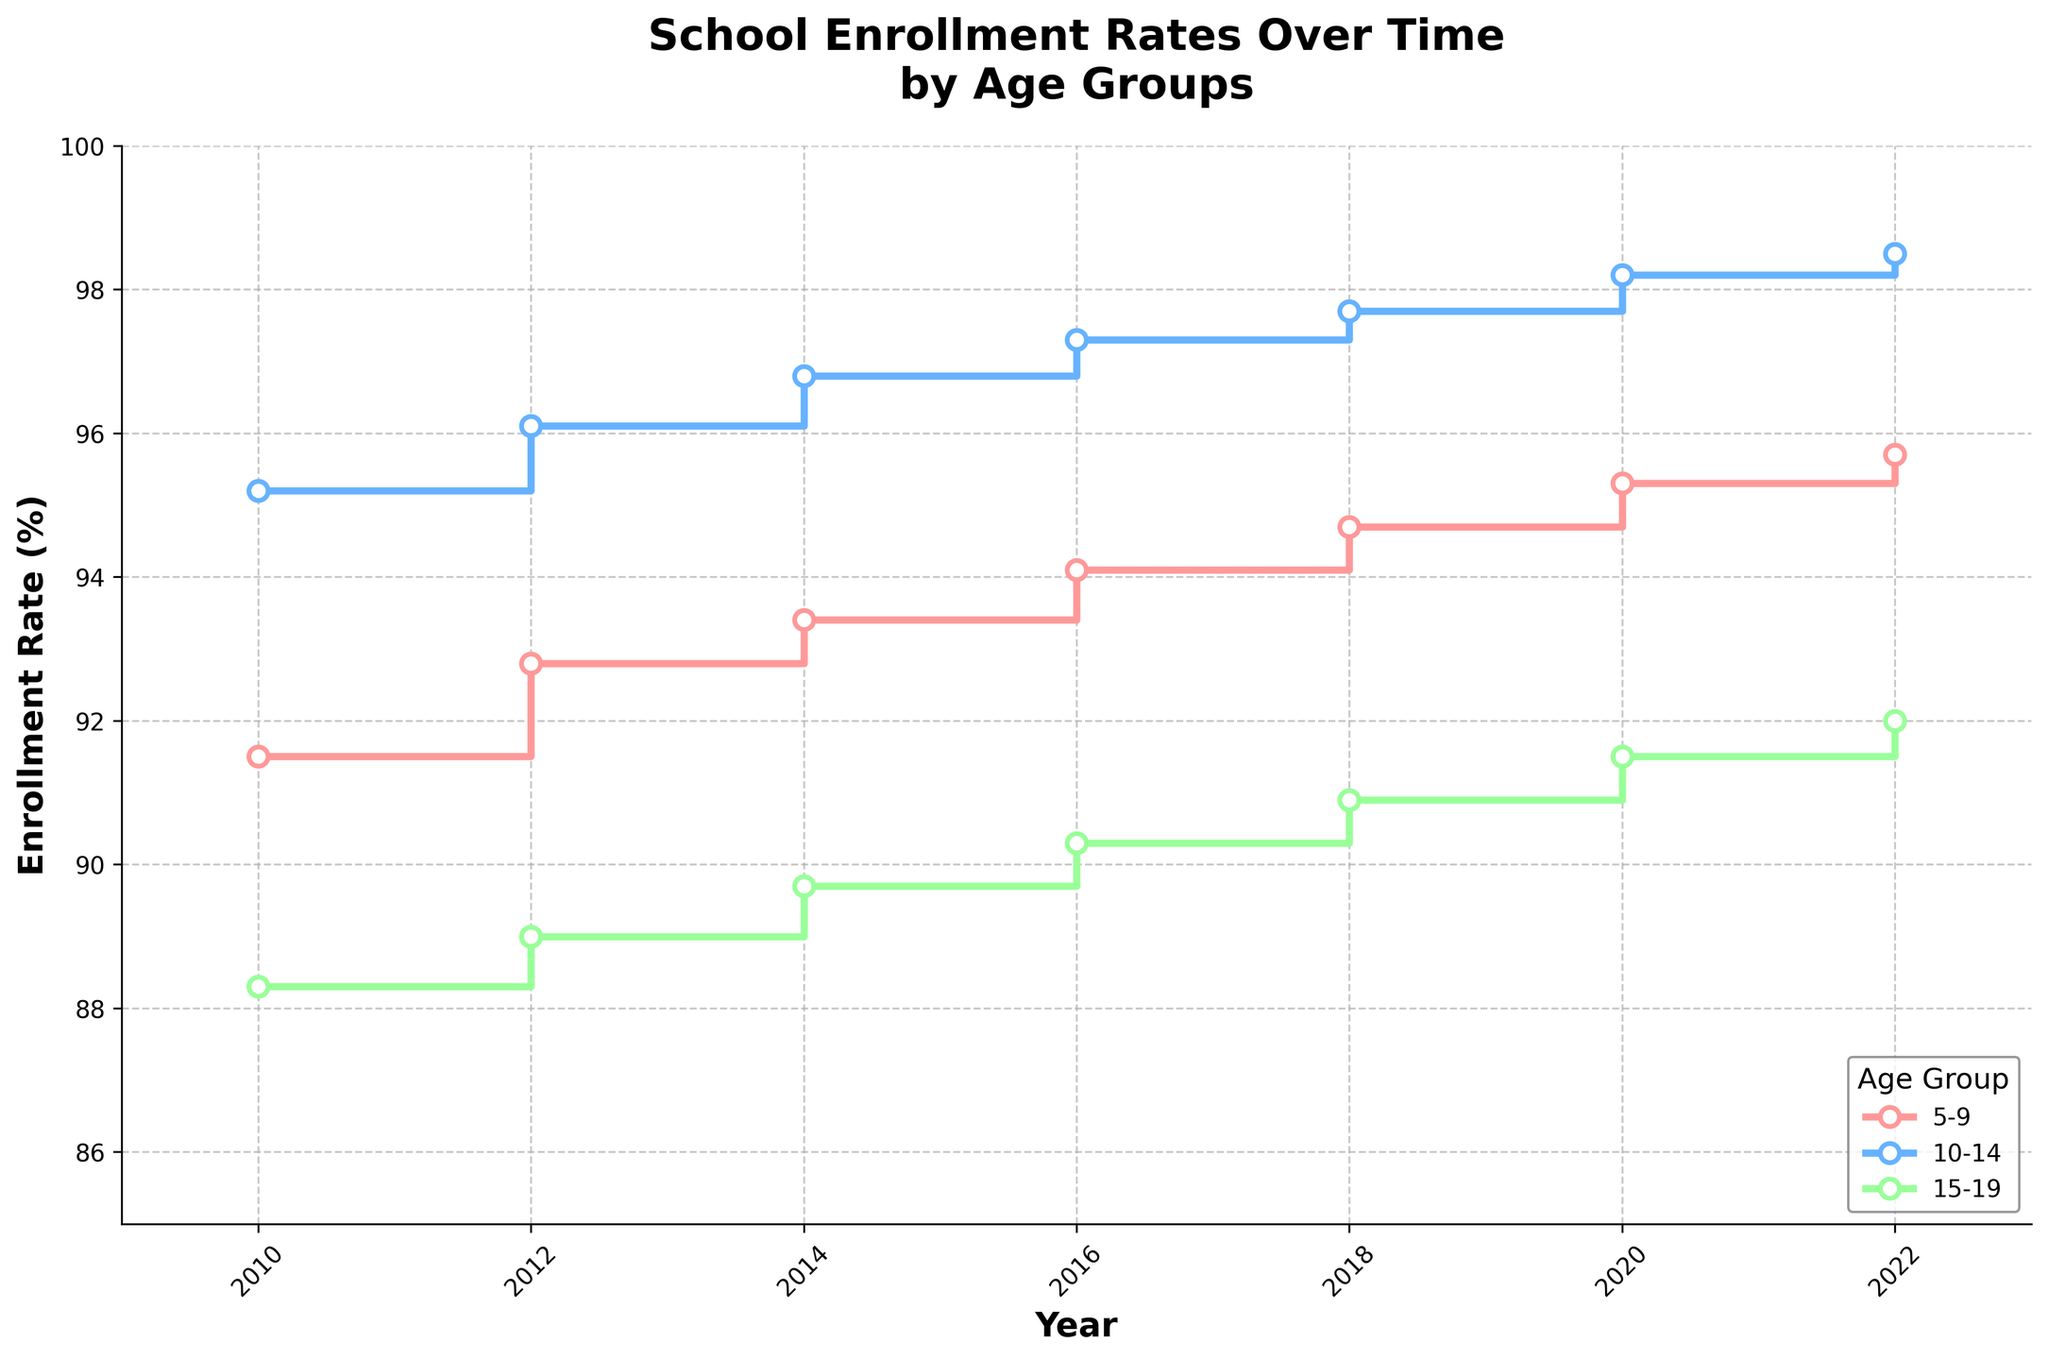What is the title of the plot? The title is located at the top of the plot, and it clearly states the main topic being visualized.
Answer: School Enrollment Rates Over Time by Age Groups Which age group had the highest enrollment rate in 2022? Look for the age group with the highest enrollment rate in 2022 by examining the endpoint of the lines in 2022 on the x-axis.
Answer: 10-14 What trend can be observed for the 15-19 age group from 2010 to 2022? Trace the stair-step line for the 15-19 age group from 2010 to 2022 and observe how the line rises, falls, or remains consistent.
Answer: Increasing What was the enrollment rate for the 5-9 age group in 2016? Identify the point on the plot where the 5-9 age group's line crosses the vertical line at 2016 on the x-axis.
Answer: 94.1% Between which two consecutive years did the 10-14 age group see the largest increase in enrollment rate? Compare the relative height differences between consecutive years for the 10-14 age group line and identify the largest increase.
Answer: 2018 and 2020 By how much did the enrollment rate for the 5-9 age group increase from 2010 to 2022? Subtract the 2010 enrollment rate from the 2022 enrollment rate for the 5-9 age group.
Answer: 4.2% Which age group showed the most consistent increase in enrollment rates over the years? Determine which age group’s stair-step line shows the least variation and a steady upward trend.
Answer: 10-14 In what year did the 10-14 age group first exceed a 97% enrollment rate? Find the first instance where the 10-14 age group's line crosses the 97% line on the y-axis.
Answer: 2016 How did the enrollment rate for the 15-19 age group change from 2014 to 2016? Identify the points on the plot for the 15-19 age group for the years 2014 and 2016 and compare them.
Answer: Increased by 0.6% What is the average enrollment rate for the 10-14 age group over the entire period? Add the enrollment rates for each year for the 10-14 age group and divide by the number of years. Calculations: (95.2 + 96.1 + 96.8 + 97.3 + 97.7 + 98.2 + 98.5) / 7 = 96.97%.
Answer: 96.97% 